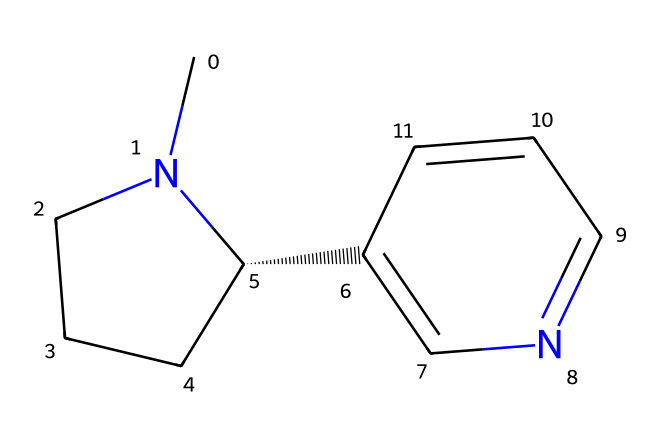What is the molecular formula of nicotine? To find the molecular formula, you can analyze the atoms represented in the SMILES notation. The structure contains 10 carbons (C), 14 hydrogens (H), and 2 nitrogens (N). Therefore, the molecular formula is assembled as C10H14N2.
Answer: C10H14N2 How many rings are present in the nicotine structure? By examining the structure indicated by the SMILES, you can see there are two ring structures present: one piperidine ring and one pyridine ring. This totals to two rings.
Answer: 2 Is nicotine a saturated or unsaturated compound? Looking closely at the bonding in the SMILES representation, the presence of double bonds (between carbon and nitrogen) indicates that nicotine contains unsaturation. Therefore, nicotine is classified as an unsaturated compound.
Answer: unsaturated What type of hybridization does the nitrogen in the nicotine structure exhibit? The nitrogen atoms in nicotine are bonded to three other atoms, which typically indicates sp2 hybridization with a trigonal planar shape. Hence, the nitrogen atom in nicotine exhibits sp2 hybridization.
Answer: sp2 Which part of nicotine is responsible for its basic character? The nitrogen atoms in the structure possess a lone pair of electrons, which can accept protons, making nicotine basic. This basic character is a result of the nitrogen's ability to interact with acids.
Answer: nitrogen Does nicotine contain any functional groups? In the nicotine structure, the presence of nitrogen directly indicates that it contains amine functional groups, which contributes to its classification in the context of chemical behavior.
Answer: amine 